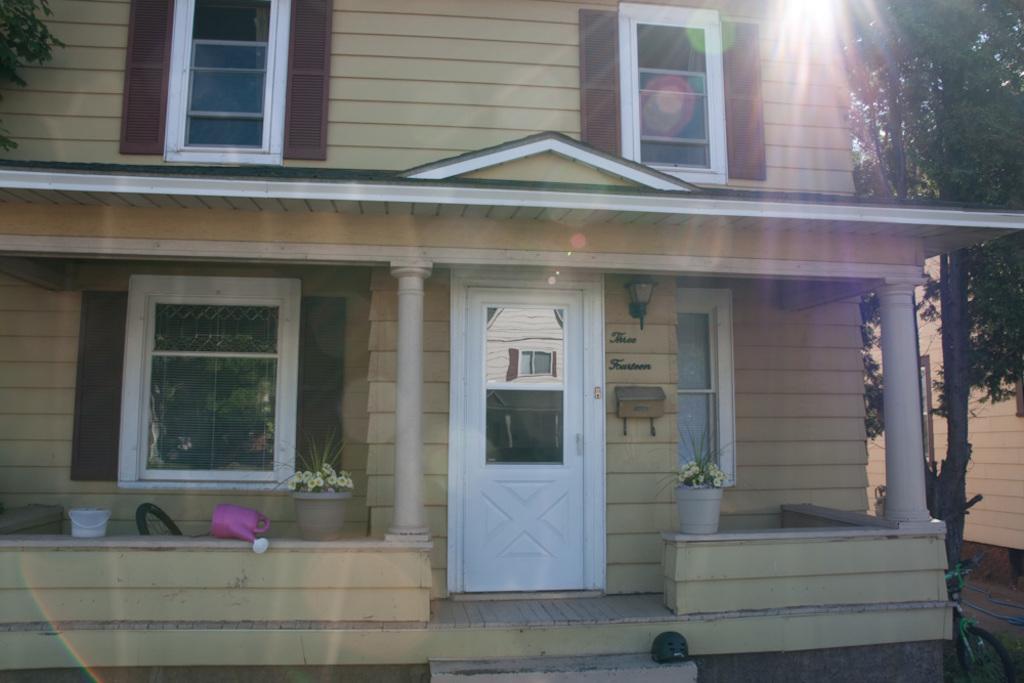Please provide a concise description of this image. In this image I can see the building with windows and the light. In-front of the building I can see the flower pot, bucket and the can. To the left I can see the tree. To the right I can see few more trees, in another building and the bicycle. 